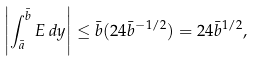Convert formula to latex. <formula><loc_0><loc_0><loc_500><loc_500>\left | \int _ { \bar { a } } ^ { \bar { b } } E \, d y \right | \leq \bar { b } ( 2 4 \bar { b } ^ { - 1 / 2 } ) = 2 4 \bar { b } ^ { 1 / 2 } ,</formula> 